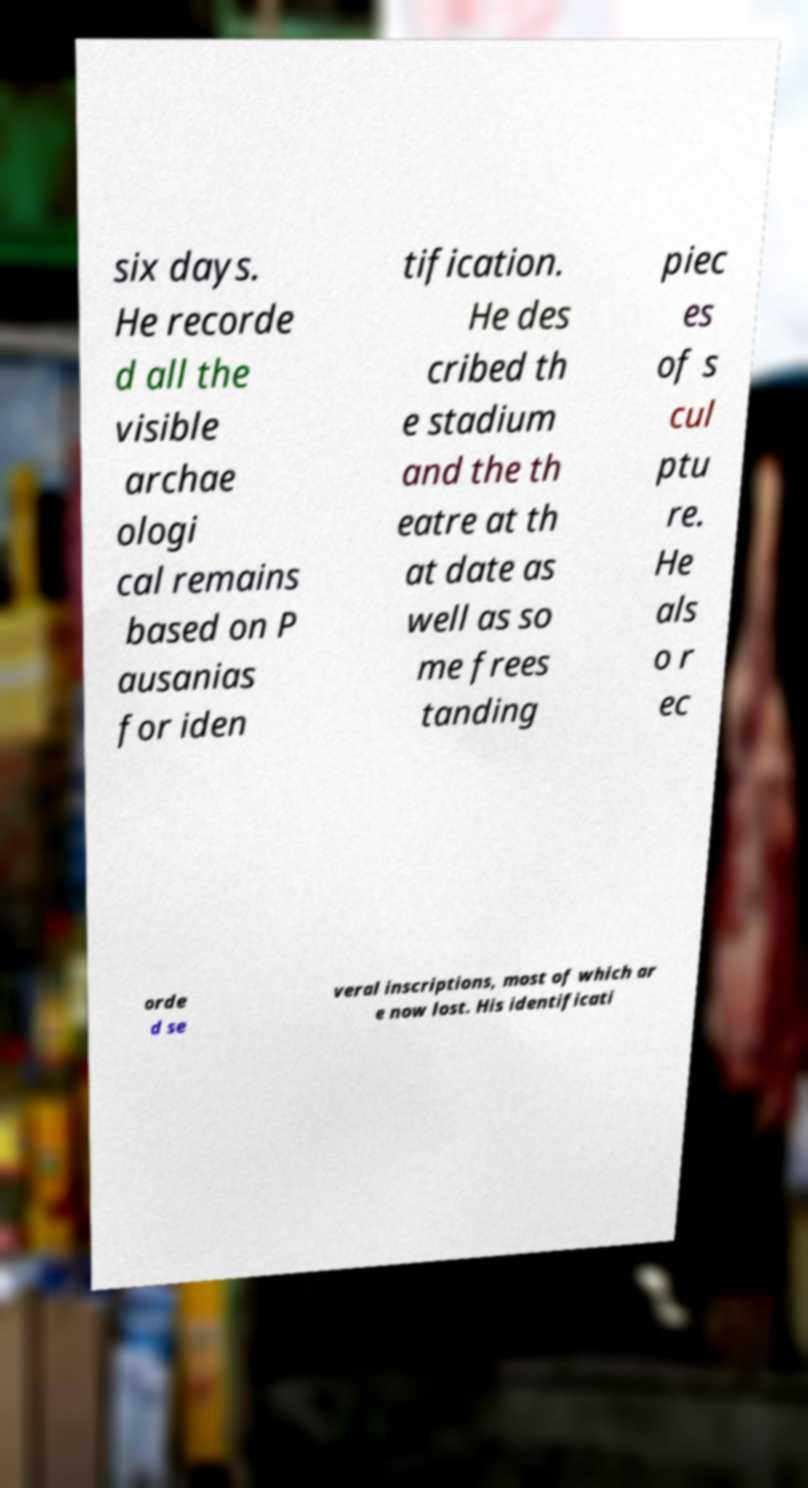Can you read and provide the text displayed in the image?This photo seems to have some interesting text. Can you extract and type it out for me? six days. He recorde d all the visible archae ologi cal remains based on P ausanias for iden tification. He des cribed th e stadium and the th eatre at th at date as well as so me frees tanding piec es of s cul ptu re. He als o r ec orde d se veral inscriptions, most of which ar e now lost. His identificati 